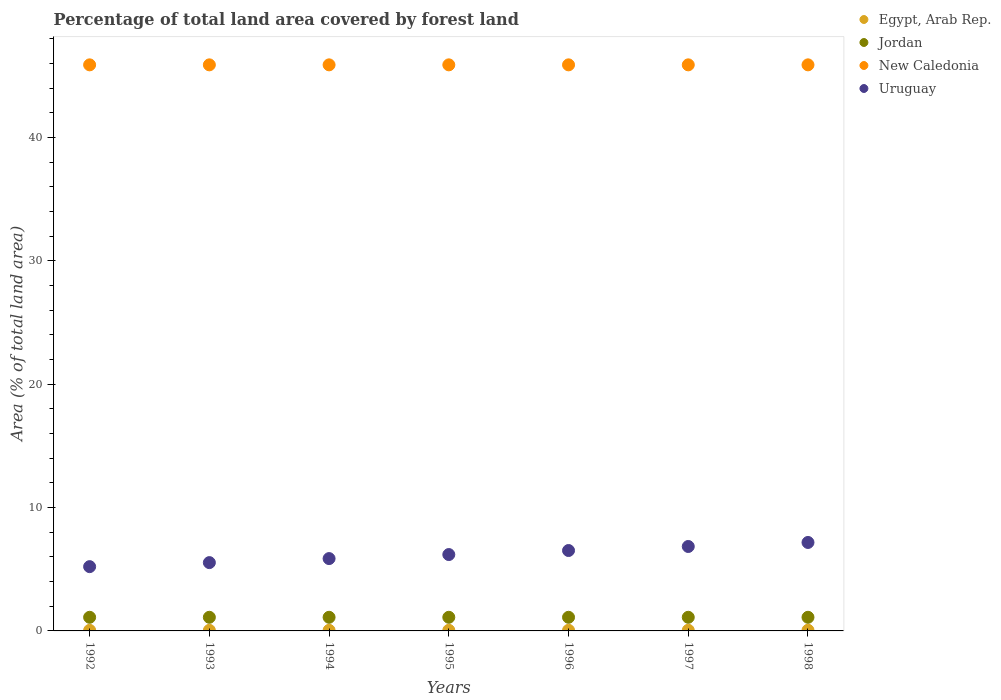How many different coloured dotlines are there?
Your response must be concise. 4. What is the percentage of forest land in New Caledonia in 1992?
Give a very brief answer. 45.9. Across all years, what is the maximum percentage of forest land in New Caledonia?
Give a very brief answer. 45.9. Across all years, what is the minimum percentage of forest land in Uruguay?
Provide a short and direct response. 5.21. In which year was the percentage of forest land in Uruguay minimum?
Keep it short and to the point. 1992. What is the total percentage of forest land in Jordan in the graph?
Provide a short and direct response. 7.73. What is the difference between the percentage of forest land in New Caledonia in 1993 and that in 1994?
Your answer should be very brief. 0. What is the difference between the percentage of forest land in Jordan in 1997 and the percentage of forest land in Uruguay in 1996?
Keep it short and to the point. -5.41. What is the average percentage of forest land in New Caledonia per year?
Provide a succinct answer. 45.9. In the year 1994, what is the difference between the percentage of forest land in Egypt, Arab Rep. and percentage of forest land in New Caledonia?
Keep it short and to the point. -45.85. What is the ratio of the percentage of forest land in Uruguay in 1994 to that in 1997?
Provide a succinct answer. 0.86. Is the percentage of forest land in Jordan in 1992 less than that in 1996?
Give a very brief answer. No. Is the difference between the percentage of forest land in Egypt, Arab Rep. in 1992 and 1995 greater than the difference between the percentage of forest land in New Caledonia in 1992 and 1995?
Ensure brevity in your answer.  No. What is the difference between the highest and the second highest percentage of forest land in Jordan?
Provide a short and direct response. 0. What is the difference between the highest and the lowest percentage of forest land in Jordan?
Your response must be concise. 0. Is the sum of the percentage of forest land in Egypt, Arab Rep. in 1994 and 1997 greater than the maximum percentage of forest land in New Caledonia across all years?
Ensure brevity in your answer.  No. Is it the case that in every year, the sum of the percentage of forest land in Jordan and percentage of forest land in New Caledonia  is greater than the percentage of forest land in Uruguay?
Your answer should be very brief. Yes. Does the percentage of forest land in Uruguay monotonically increase over the years?
Provide a succinct answer. Yes. Is the percentage of forest land in Egypt, Arab Rep. strictly greater than the percentage of forest land in New Caledonia over the years?
Your answer should be very brief. No. How many years are there in the graph?
Provide a short and direct response. 7. Does the graph contain grids?
Give a very brief answer. No. How many legend labels are there?
Your answer should be very brief. 4. What is the title of the graph?
Your answer should be compact. Percentage of total land area covered by forest land. What is the label or title of the X-axis?
Your answer should be compact. Years. What is the label or title of the Y-axis?
Keep it short and to the point. Area (% of total land area). What is the Area (% of total land area) of Egypt, Arab Rep. in 1992?
Your response must be concise. 0.05. What is the Area (% of total land area) of Jordan in 1992?
Provide a short and direct response. 1.1. What is the Area (% of total land area) in New Caledonia in 1992?
Offer a terse response. 45.9. What is the Area (% of total land area) in Uruguay in 1992?
Offer a very short reply. 5.21. What is the Area (% of total land area) of Egypt, Arab Rep. in 1993?
Provide a succinct answer. 0.05. What is the Area (% of total land area) in Jordan in 1993?
Ensure brevity in your answer.  1.1. What is the Area (% of total land area) of New Caledonia in 1993?
Offer a terse response. 45.9. What is the Area (% of total land area) in Uruguay in 1993?
Provide a succinct answer. 5.54. What is the Area (% of total land area) in Egypt, Arab Rep. in 1994?
Offer a very short reply. 0.05. What is the Area (% of total land area) in Jordan in 1994?
Ensure brevity in your answer.  1.1. What is the Area (% of total land area) of New Caledonia in 1994?
Make the answer very short. 45.9. What is the Area (% of total land area) in Uruguay in 1994?
Your answer should be very brief. 5.87. What is the Area (% of total land area) in Egypt, Arab Rep. in 1995?
Give a very brief answer. 0.05. What is the Area (% of total land area) of Jordan in 1995?
Provide a short and direct response. 1.1. What is the Area (% of total land area) in New Caledonia in 1995?
Keep it short and to the point. 45.9. What is the Area (% of total land area) of Uruguay in 1995?
Make the answer very short. 6.19. What is the Area (% of total land area) of Egypt, Arab Rep. in 1996?
Give a very brief answer. 0.05. What is the Area (% of total land area) of Jordan in 1996?
Provide a short and direct response. 1.1. What is the Area (% of total land area) in New Caledonia in 1996?
Give a very brief answer. 45.9. What is the Area (% of total land area) of Uruguay in 1996?
Your answer should be very brief. 6.52. What is the Area (% of total land area) of Egypt, Arab Rep. in 1997?
Give a very brief answer. 0.05. What is the Area (% of total land area) of Jordan in 1997?
Give a very brief answer. 1.1. What is the Area (% of total land area) of New Caledonia in 1997?
Make the answer very short. 45.9. What is the Area (% of total land area) of Uruguay in 1997?
Your response must be concise. 6.85. What is the Area (% of total land area) of Egypt, Arab Rep. in 1998?
Offer a terse response. 0.06. What is the Area (% of total land area) of Jordan in 1998?
Make the answer very short. 1.1. What is the Area (% of total land area) of New Caledonia in 1998?
Offer a terse response. 45.9. What is the Area (% of total land area) of Uruguay in 1998?
Offer a very short reply. 7.17. Across all years, what is the maximum Area (% of total land area) in Egypt, Arab Rep.?
Make the answer very short. 0.06. Across all years, what is the maximum Area (% of total land area) of Jordan?
Make the answer very short. 1.1. Across all years, what is the maximum Area (% of total land area) in New Caledonia?
Your answer should be very brief. 45.9. Across all years, what is the maximum Area (% of total land area) of Uruguay?
Your answer should be compact. 7.17. Across all years, what is the minimum Area (% of total land area) in Egypt, Arab Rep.?
Ensure brevity in your answer.  0.05. Across all years, what is the minimum Area (% of total land area) of Jordan?
Offer a terse response. 1.1. Across all years, what is the minimum Area (% of total land area) in New Caledonia?
Make the answer very short. 45.9. Across all years, what is the minimum Area (% of total land area) in Uruguay?
Ensure brevity in your answer.  5.21. What is the total Area (% of total land area) in Egypt, Arab Rep. in the graph?
Offer a very short reply. 0.36. What is the total Area (% of total land area) in Jordan in the graph?
Your answer should be very brief. 7.73. What is the total Area (% of total land area) in New Caledonia in the graph?
Your response must be concise. 321.28. What is the total Area (% of total land area) of Uruguay in the graph?
Ensure brevity in your answer.  43.34. What is the difference between the Area (% of total land area) of Egypt, Arab Rep. in 1992 and that in 1993?
Give a very brief answer. -0. What is the difference between the Area (% of total land area) of Uruguay in 1992 and that in 1993?
Your answer should be compact. -0.33. What is the difference between the Area (% of total land area) of Egypt, Arab Rep. in 1992 and that in 1994?
Provide a short and direct response. -0. What is the difference between the Area (% of total land area) in Jordan in 1992 and that in 1994?
Provide a short and direct response. 0. What is the difference between the Area (% of total land area) of Uruguay in 1992 and that in 1994?
Make the answer very short. -0.65. What is the difference between the Area (% of total land area) in Egypt, Arab Rep. in 1992 and that in 1995?
Ensure brevity in your answer.  -0. What is the difference between the Area (% of total land area) of Jordan in 1992 and that in 1995?
Make the answer very short. 0. What is the difference between the Area (% of total land area) in Uruguay in 1992 and that in 1995?
Give a very brief answer. -0.98. What is the difference between the Area (% of total land area) of Egypt, Arab Rep. in 1992 and that in 1996?
Your answer should be compact. -0.01. What is the difference between the Area (% of total land area) in Jordan in 1992 and that in 1996?
Your answer should be compact. 0. What is the difference between the Area (% of total land area) of Uruguay in 1992 and that in 1996?
Your response must be concise. -1.31. What is the difference between the Area (% of total land area) in Egypt, Arab Rep. in 1992 and that in 1997?
Provide a short and direct response. -0.01. What is the difference between the Area (% of total land area) in Uruguay in 1992 and that in 1997?
Give a very brief answer. -1.63. What is the difference between the Area (% of total land area) of Egypt, Arab Rep. in 1992 and that in 1998?
Provide a succinct answer. -0.01. What is the difference between the Area (% of total land area) in Uruguay in 1992 and that in 1998?
Ensure brevity in your answer.  -1.96. What is the difference between the Area (% of total land area) in Egypt, Arab Rep. in 1993 and that in 1994?
Your response must be concise. -0. What is the difference between the Area (% of total land area) of Uruguay in 1993 and that in 1994?
Ensure brevity in your answer.  -0.33. What is the difference between the Area (% of total land area) in Egypt, Arab Rep. in 1993 and that in 1995?
Your answer should be very brief. -0. What is the difference between the Area (% of total land area) in Jordan in 1993 and that in 1995?
Make the answer very short. 0. What is the difference between the Area (% of total land area) in New Caledonia in 1993 and that in 1995?
Give a very brief answer. 0. What is the difference between the Area (% of total land area) of Uruguay in 1993 and that in 1995?
Make the answer very short. -0.65. What is the difference between the Area (% of total land area) in Egypt, Arab Rep. in 1993 and that in 1996?
Give a very brief answer. -0. What is the difference between the Area (% of total land area) in Uruguay in 1993 and that in 1996?
Offer a very short reply. -0.98. What is the difference between the Area (% of total land area) in Egypt, Arab Rep. in 1993 and that in 1997?
Make the answer very short. -0.01. What is the difference between the Area (% of total land area) of Jordan in 1993 and that in 1997?
Offer a very short reply. 0. What is the difference between the Area (% of total land area) in Uruguay in 1993 and that in 1997?
Offer a very short reply. -1.31. What is the difference between the Area (% of total land area) in Egypt, Arab Rep. in 1993 and that in 1998?
Your answer should be compact. -0.01. What is the difference between the Area (% of total land area) in Jordan in 1993 and that in 1998?
Give a very brief answer. 0. What is the difference between the Area (% of total land area) in New Caledonia in 1993 and that in 1998?
Your answer should be very brief. 0. What is the difference between the Area (% of total land area) in Uruguay in 1993 and that in 1998?
Your answer should be compact. -1.63. What is the difference between the Area (% of total land area) of Egypt, Arab Rep. in 1994 and that in 1995?
Your response must be concise. -0. What is the difference between the Area (% of total land area) in Uruguay in 1994 and that in 1995?
Offer a very short reply. -0.33. What is the difference between the Area (% of total land area) of Egypt, Arab Rep. in 1994 and that in 1996?
Ensure brevity in your answer.  -0. What is the difference between the Area (% of total land area) of Uruguay in 1994 and that in 1996?
Ensure brevity in your answer.  -0.65. What is the difference between the Area (% of total land area) in Egypt, Arab Rep. in 1994 and that in 1997?
Make the answer very short. -0. What is the difference between the Area (% of total land area) in New Caledonia in 1994 and that in 1997?
Provide a short and direct response. 0. What is the difference between the Area (% of total land area) in Uruguay in 1994 and that in 1997?
Your answer should be very brief. -0.98. What is the difference between the Area (% of total land area) of Egypt, Arab Rep. in 1994 and that in 1998?
Your answer should be compact. -0.01. What is the difference between the Area (% of total land area) of Jordan in 1994 and that in 1998?
Your response must be concise. 0. What is the difference between the Area (% of total land area) of Uruguay in 1994 and that in 1998?
Give a very brief answer. -1.31. What is the difference between the Area (% of total land area) in Egypt, Arab Rep. in 1995 and that in 1996?
Provide a short and direct response. -0. What is the difference between the Area (% of total land area) in Jordan in 1995 and that in 1996?
Your response must be concise. 0. What is the difference between the Area (% of total land area) of New Caledonia in 1995 and that in 1996?
Ensure brevity in your answer.  0. What is the difference between the Area (% of total land area) of Uruguay in 1995 and that in 1996?
Provide a succinct answer. -0.33. What is the difference between the Area (% of total land area) of Egypt, Arab Rep. in 1995 and that in 1997?
Ensure brevity in your answer.  -0. What is the difference between the Area (% of total land area) of Jordan in 1995 and that in 1997?
Offer a very short reply. 0. What is the difference between the Area (% of total land area) in Uruguay in 1995 and that in 1997?
Give a very brief answer. -0.65. What is the difference between the Area (% of total land area) of Egypt, Arab Rep. in 1995 and that in 1998?
Ensure brevity in your answer.  -0. What is the difference between the Area (% of total land area) of New Caledonia in 1995 and that in 1998?
Your answer should be very brief. 0. What is the difference between the Area (% of total land area) in Uruguay in 1995 and that in 1998?
Your response must be concise. -0.98. What is the difference between the Area (% of total land area) of Egypt, Arab Rep. in 1996 and that in 1997?
Provide a short and direct response. -0. What is the difference between the Area (% of total land area) of Jordan in 1996 and that in 1997?
Ensure brevity in your answer.  0. What is the difference between the Area (% of total land area) in New Caledonia in 1996 and that in 1997?
Your response must be concise. 0. What is the difference between the Area (% of total land area) in Uruguay in 1996 and that in 1997?
Provide a succinct answer. -0.33. What is the difference between the Area (% of total land area) in Egypt, Arab Rep. in 1996 and that in 1998?
Give a very brief answer. -0. What is the difference between the Area (% of total land area) of Jordan in 1996 and that in 1998?
Make the answer very short. 0. What is the difference between the Area (% of total land area) in New Caledonia in 1996 and that in 1998?
Your answer should be very brief. 0. What is the difference between the Area (% of total land area) in Uruguay in 1996 and that in 1998?
Your answer should be very brief. -0.65. What is the difference between the Area (% of total land area) in Egypt, Arab Rep. in 1997 and that in 1998?
Offer a very short reply. -0. What is the difference between the Area (% of total land area) of New Caledonia in 1997 and that in 1998?
Give a very brief answer. 0. What is the difference between the Area (% of total land area) of Uruguay in 1997 and that in 1998?
Your answer should be very brief. -0.33. What is the difference between the Area (% of total land area) in Egypt, Arab Rep. in 1992 and the Area (% of total land area) in Jordan in 1993?
Give a very brief answer. -1.06. What is the difference between the Area (% of total land area) in Egypt, Arab Rep. in 1992 and the Area (% of total land area) in New Caledonia in 1993?
Offer a terse response. -45.85. What is the difference between the Area (% of total land area) of Egypt, Arab Rep. in 1992 and the Area (% of total land area) of Uruguay in 1993?
Provide a succinct answer. -5.49. What is the difference between the Area (% of total land area) of Jordan in 1992 and the Area (% of total land area) of New Caledonia in 1993?
Your answer should be compact. -44.79. What is the difference between the Area (% of total land area) of Jordan in 1992 and the Area (% of total land area) of Uruguay in 1993?
Keep it short and to the point. -4.43. What is the difference between the Area (% of total land area) of New Caledonia in 1992 and the Area (% of total land area) of Uruguay in 1993?
Make the answer very short. 40.36. What is the difference between the Area (% of total land area) in Egypt, Arab Rep. in 1992 and the Area (% of total land area) in Jordan in 1994?
Your answer should be compact. -1.06. What is the difference between the Area (% of total land area) of Egypt, Arab Rep. in 1992 and the Area (% of total land area) of New Caledonia in 1994?
Offer a terse response. -45.85. What is the difference between the Area (% of total land area) in Egypt, Arab Rep. in 1992 and the Area (% of total land area) in Uruguay in 1994?
Make the answer very short. -5.82. What is the difference between the Area (% of total land area) in Jordan in 1992 and the Area (% of total land area) in New Caledonia in 1994?
Offer a terse response. -44.79. What is the difference between the Area (% of total land area) in Jordan in 1992 and the Area (% of total land area) in Uruguay in 1994?
Ensure brevity in your answer.  -4.76. What is the difference between the Area (% of total land area) of New Caledonia in 1992 and the Area (% of total land area) of Uruguay in 1994?
Provide a short and direct response. 40.03. What is the difference between the Area (% of total land area) of Egypt, Arab Rep. in 1992 and the Area (% of total land area) of Jordan in 1995?
Your answer should be very brief. -1.06. What is the difference between the Area (% of total land area) of Egypt, Arab Rep. in 1992 and the Area (% of total land area) of New Caledonia in 1995?
Keep it short and to the point. -45.85. What is the difference between the Area (% of total land area) of Egypt, Arab Rep. in 1992 and the Area (% of total land area) of Uruguay in 1995?
Your answer should be very brief. -6.14. What is the difference between the Area (% of total land area) in Jordan in 1992 and the Area (% of total land area) in New Caledonia in 1995?
Provide a succinct answer. -44.79. What is the difference between the Area (% of total land area) in Jordan in 1992 and the Area (% of total land area) in Uruguay in 1995?
Your response must be concise. -5.09. What is the difference between the Area (% of total land area) in New Caledonia in 1992 and the Area (% of total land area) in Uruguay in 1995?
Offer a very short reply. 39.7. What is the difference between the Area (% of total land area) in Egypt, Arab Rep. in 1992 and the Area (% of total land area) in Jordan in 1996?
Keep it short and to the point. -1.06. What is the difference between the Area (% of total land area) of Egypt, Arab Rep. in 1992 and the Area (% of total land area) of New Caledonia in 1996?
Your answer should be very brief. -45.85. What is the difference between the Area (% of total land area) of Egypt, Arab Rep. in 1992 and the Area (% of total land area) of Uruguay in 1996?
Your answer should be very brief. -6.47. What is the difference between the Area (% of total land area) of Jordan in 1992 and the Area (% of total land area) of New Caledonia in 1996?
Your answer should be compact. -44.79. What is the difference between the Area (% of total land area) in Jordan in 1992 and the Area (% of total land area) in Uruguay in 1996?
Your response must be concise. -5.41. What is the difference between the Area (% of total land area) in New Caledonia in 1992 and the Area (% of total land area) in Uruguay in 1996?
Keep it short and to the point. 39.38. What is the difference between the Area (% of total land area) of Egypt, Arab Rep. in 1992 and the Area (% of total land area) of Jordan in 1997?
Your answer should be very brief. -1.06. What is the difference between the Area (% of total land area) of Egypt, Arab Rep. in 1992 and the Area (% of total land area) of New Caledonia in 1997?
Make the answer very short. -45.85. What is the difference between the Area (% of total land area) in Egypt, Arab Rep. in 1992 and the Area (% of total land area) in Uruguay in 1997?
Your response must be concise. -6.8. What is the difference between the Area (% of total land area) in Jordan in 1992 and the Area (% of total land area) in New Caledonia in 1997?
Give a very brief answer. -44.79. What is the difference between the Area (% of total land area) of Jordan in 1992 and the Area (% of total land area) of Uruguay in 1997?
Ensure brevity in your answer.  -5.74. What is the difference between the Area (% of total land area) of New Caledonia in 1992 and the Area (% of total land area) of Uruguay in 1997?
Offer a very short reply. 39.05. What is the difference between the Area (% of total land area) of Egypt, Arab Rep. in 1992 and the Area (% of total land area) of Jordan in 1998?
Make the answer very short. -1.06. What is the difference between the Area (% of total land area) in Egypt, Arab Rep. in 1992 and the Area (% of total land area) in New Caledonia in 1998?
Offer a very short reply. -45.85. What is the difference between the Area (% of total land area) of Egypt, Arab Rep. in 1992 and the Area (% of total land area) of Uruguay in 1998?
Make the answer very short. -7.13. What is the difference between the Area (% of total land area) in Jordan in 1992 and the Area (% of total land area) in New Caledonia in 1998?
Your answer should be compact. -44.79. What is the difference between the Area (% of total land area) of Jordan in 1992 and the Area (% of total land area) of Uruguay in 1998?
Offer a very short reply. -6.07. What is the difference between the Area (% of total land area) in New Caledonia in 1992 and the Area (% of total land area) in Uruguay in 1998?
Provide a short and direct response. 38.72. What is the difference between the Area (% of total land area) of Egypt, Arab Rep. in 1993 and the Area (% of total land area) of Jordan in 1994?
Offer a very short reply. -1.06. What is the difference between the Area (% of total land area) of Egypt, Arab Rep. in 1993 and the Area (% of total land area) of New Caledonia in 1994?
Give a very brief answer. -45.85. What is the difference between the Area (% of total land area) in Egypt, Arab Rep. in 1993 and the Area (% of total land area) in Uruguay in 1994?
Offer a terse response. -5.82. What is the difference between the Area (% of total land area) of Jordan in 1993 and the Area (% of total land area) of New Caledonia in 1994?
Your answer should be compact. -44.79. What is the difference between the Area (% of total land area) of Jordan in 1993 and the Area (% of total land area) of Uruguay in 1994?
Offer a very short reply. -4.76. What is the difference between the Area (% of total land area) in New Caledonia in 1993 and the Area (% of total land area) in Uruguay in 1994?
Your answer should be compact. 40.03. What is the difference between the Area (% of total land area) of Egypt, Arab Rep. in 1993 and the Area (% of total land area) of Jordan in 1995?
Make the answer very short. -1.06. What is the difference between the Area (% of total land area) in Egypt, Arab Rep. in 1993 and the Area (% of total land area) in New Caledonia in 1995?
Ensure brevity in your answer.  -45.85. What is the difference between the Area (% of total land area) of Egypt, Arab Rep. in 1993 and the Area (% of total land area) of Uruguay in 1995?
Give a very brief answer. -6.14. What is the difference between the Area (% of total land area) in Jordan in 1993 and the Area (% of total land area) in New Caledonia in 1995?
Make the answer very short. -44.79. What is the difference between the Area (% of total land area) in Jordan in 1993 and the Area (% of total land area) in Uruguay in 1995?
Offer a terse response. -5.09. What is the difference between the Area (% of total land area) in New Caledonia in 1993 and the Area (% of total land area) in Uruguay in 1995?
Make the answer very short. 39.7. What is the difference between the Area (% of total land area) of Egypt, Arab Rep. in 1993 and the Area (% of total land area) of Jordan in 1996?
Give a very brief answer. -1.06. What is the difference between the Area (% of total land area) of Egypt, Arab Rep. in 1993 and the Area (% of total land area) of New Caledonia in 1996?
Provide a short and direct response. -45.85. What is the difference between the Area (% of total land area) of Egypt, Arab Rep. in 1993 and the Area (% of total land area) of Uruguay in 1996?
Offer a terse response. -6.47. What is the difference between the Area (% of total land area) in Jordan in 1993 and the Area (% of total land area) in New Caledonia in 1996?
Your answer should be compact. -44.79. What is the difference between the Area (% of total land area) in Jordan in 1993 and the Area (% of total land area) in Uruguay in 1996?
Your answer should be compact. -5.41. What is the difference between the Area (% of total land area) of New Caledonia in 1993 and the Area (% of total land area) of Uruguay in 1996?
Your answer should be very brief. 39.38. What is the difference between the Area (% of total land area) in Egypt, Arab Rep. in 1993 and the Area (% of total land area) in Jordan in 1997?
Offer a terse response. -1.06. What is the difference between the Area (% of total land area) in Egypt, Arab Rep. in 1993 and the Area (% of total land area) in New Caledonia in 1997?
Your answer should be compact. -45.85. What is the difference between the Area (% of total land area) of Egypt, Arab Rep. in 1993 and the Area (% of total land area) of Uruguay in 1997?
Offer a terse response. -6.8. What is the difference between the Area (% of total land area) of Jordan in 1993 and the Area (% of total land area) of New Caledonia in 1997?
Offer a terse response. -44.79. What is the difference between the Area (% of total land area) of Jordan in 1993 and the Area (% of total land area) of Uruguay in 1997?
Your response must be concise. -5.74. What is the difference between the Area (% of total land area) in New Caledonia in 1993 and the Area (% of total land area) in Uruguay in 1997?
Offer a very short reply. 39.05. What is the difference between the Area (% of total land area) in Egypt, Arab Rep. in 1993 and the Area (% of total land area) in Jordan in 1998?
Provide a short and direct response. -1.06. What is the difference between the Area (% of total land area) of Egypt, Arab Rep. in 1993 and the Area (% of total land area) of New Caledonia in 1998?
Provide a succinct answer. -45.85. What is the difference between the Area (% of total land area) in Egypt, Arab Rep. in 1993 and the Area (% of total land area) in Uruguay in 1998?
Provide a succinct answer. -7.12. What is the difference between the Area (% of total land area) of Jordan in 1993 and the Area (% of total land area) of New Caledonia in 1998?
Offer a very short reply. -44.79. What is the difference between the Area (% of total land area) in Jordan in 1993 and the Area (% of total land area) in Uruguay in 1998?
Ensure brevity in your answer.  -6.07. What is the difference between the Area (% of total land area) in New Caledonia in 1993 and the Area (% of total land area) in Uruguay in 1998?
Make the answer very short. 38.72. What is the difference between the Area (% of total land area) of Egypt, Arab Rep. in 1994 and the Area (% of total land area) of Jordan in 1995?
Your response must be concise. -1.05. What is the difference between the Area (% of total land area) in Egypt, Arab Rep. in 1994 and the Area (% of total land area) in New Caledonia in 1995?
Keep it short and to the point. -45.85. What is the difference between the Area (% of total land area) in Egypt, Arab Rep. in 1994 and the Area (% of total land area) in Uruguay in 1995?
Keep it short and to the point. -6.14. What is the difference between the Area (% of total land area) of Jordan in 1994 and the Area (% of total land area) of New Caledonia in 1995?
Provide a short and direct response. -44.79. What is the difference between the Area (% of total land area) of Jordan in 1994 and the Area (% of total land area) of Uruguay in 1995?
Your response must be concise. -5.09. What is the difference between the Area (% of total land area) in New Caledonia in 1994 and the Area (% of total land area) in Uruguay in 1995?
Your answer should be very brief. 39.7. What is the difference between the Area (% of total land area) of Egypt, Arab Rep. in 1994 and the Area (% of total land area) of Jordan in 1996?
Your answer should be very brief. -1.05. What is the difference between the Area (% of total land area) of Egypt, Arab Rep. in 1994 and the Area (% of total land area) of New Caledonia in 1996?
Make the answer very short. -45.85. What is the difference between the Area (% of total land area) of Egypt, Arab Rep. in 1994 and the Area (% of total land area) of Uruguay in 1996?
Your answer should be compact. -6.47. What is the difference between the Area (% of total land area) in Jordan in 1994 and the Area (% of total land area) in New Caledonia in 1996?
Ensure brevity in your answer.  -44.79. What is the difference between the Area (% of total land area) of Jordan in 1994 and the Area (% of total land area) of Uruguay in 1996?
Your response must be concise. -5.41. What is the difference between the Area (% of total land area) in New Caledonia in 1994 and the Area (% of total land area) in Uruguay in 1996?
Your answer should be very brief. 39.38. What is the difference between the Area (% of total land area) of Egypt, Arab Rep. in 1994 and the Area (% of total land area) of Jordan in 1997?
Provide a short and direct response. -1.05. What is the difference between the Area (% of total land area) in Egypt, Arab Rep. in 1994 and the Area (% of total land area) in New Caledonia in 1997?
Your response must be concise. -45.85. What is the difference between the Area (% of total land area) of Egypt, Arab Rep. in 1994 and the Area (% of total land area) of Uruguay in 1997?
Give a very brief answer. -6.8. What is the difference between the Area (% of total land area) in Jordan in 1994 and the Area (% of total land area) in New Caledonia in 1997?
Provide a short and direct response. -44.79. What is the difference between the Area (% of total land area) of Jordan in 1994 and the Area (% of total land area) of Uruguay in 1997?
Ensure brevity in your answer.  -5.74. What is the difference between the Area (% of total land area) of New Caledonia in 1994 and the Area (% of total land area) of Uruguay in 1997?
Make the answer very short. 39.05. What is the difference between the Area (% of total land area) of Egypt, Arab Rep. in 1994 and the Area (% of total land area) of Jordan in 1998?
Offer a very short reply. -1.05. What is the difference between the Area (% of total land area) of Egypt, Arab Rep. in 1994 and the Area (% of total land area) of New Caledonia in 1998?
Give a very brief answer. -45.85. What is the difference between the Area (% of total land area) of Egypt, Arab Rep. in 1994 and the Area (% of total land area) of Uruguay in 1998?
Keep it short and to the point. -7.12. What is the difference between the Area (% of total land area) of Jordan in 1994 and the Area (% of total land area) of New Caledonia in 1998?
Provide a succinct answer. -44.79. What is the difference between the Area (% of total land area) of Jordan in 1994 and the Area (% of total land area) of Uruguay in 1998?
Offer a terse response. -6.07. What is the difference between the Area (% of total land area) of New Caledonia in 1994 and the Area (% of total land area) of Uruguay in 1998?
Your answer should be compact. 38.72. What is the difference between the Area (% of total land area) in Egypt, Arab Rep. in 1995 and the Area (% of total land area) in Jordan in 1996?
Give a very brief answer. -1.05. What is the difference between the Area (% of total land area) in Egypt, Arab Rep. in 1995 and the Area (% of total land area) in New Caledonia in 1996?
Your answer should be compact. -45.85. What is the difference between the Area (% of total land area) in Egypt, Arab Rep. in 1995 and the Area (% of total land area) in Uruguay in 1996?
Your response must be concise. -6.47. What is the difference between the Area (% of total land area) in Jordan in 1995 and the Area (% of total land area) in New Caledonia in 1996?
Provide a succinct answer. -44.79. What is the difference between the Area (% of total land area) of Jordan in 1995 and the Area (% of total land area) of Uruguay in 1996?
Provide a succinct answer. -5.41. What is the difference between the Area (% of total land area) in New Caledonia in 1995 and the Area (% of total land area) in Uruguay in 1996?
Keep it short and to the point. 39.38. What is the difference between the Area (% of total land area) of Egypt, Arab Rep. in 1995 and the Area (% of total land area) of Jordan in 1997?
Your answer should be very brief. -1.05. What is the difference between the Area (% of total land area) of Egypt, Arab Rep. in 1995 and the Area (% of total land area) of New Caledonia in 1997?
Offer a terse response. -45.85. What is the difference between the Area (% of total land area) in Egypt, Arab Rep. in 1995 and the Area (% of total land area) in Uruguay in 1997?
Offer a terse response. -6.79. What is the difference between the Area (% of total land area) in Jordan in 1995 and the Area (% of total land area) in New Caledonia in 1997?
Keep it short and to the point. -44.79. What is the difference between the Area (% of total land area) in Jordan in 1995 and the Area (% of total land area) in Uruguay in 1997?
Make the answer very short. -5.74. What is the difference between the Area (% of total land area) of New Caledonia in 1995 and the Area (% of total land area) of Uruguay in 1997?
Offer a terse response. 39.05. What is the difference between the Area (% of total land area) in Egypt, Arab Rep. in 1995 and the Area (% of total land area) in Jordan in 1998?
Your answer should be very brief. -1.05. What is the difference between the Area (% of total land area) of Egypt, Arab Rep. in 1995 and the Area (% of total land area) of New Caledonia in 1998?
Your response must be concise. -45.85. What is the difference between the Area (% of total land area) in Egypt, Arab Rep. in 1995 and the Area (% of total land area) in Uruguay in 1998?
Your answer should be compact. -7.12. What is the difference between the Area (% of total land area) of Jordan in 1995 and the Area (% of total land area) of New Caledonia in 1998?
Offer a very short reply. -44.79. What is the difference between the Area (% of total land area) in Jordan in 1995 and the Area (% of total land area) in Uruguay in 1998?
Your response must be concise. -6.07. What is the difference between the Area (% of total land area) in New Caledonia in 1995 and the Area (% of total land area) in Uruguay in 1998?
Provide a succinct answer. 38.72. What is the difference between the Area (% of total land area) in Egypt, Arab Rep. in 1996 and the Area (% of total land area) in Jordan in 1997?
Your answer should be compact. -1.05. What is the difference between the Area (% of total land area) of Egypt, Arab Rep. in 1996 and the Area (% of total land area) of New Caledonia in 1997?
Your response must be concise. -45.84. What is the difference between the Area (% of total land area) of Egypt, Arab Rep. in 1996 and the Area (% of total land area) of Uruguay in 1997?
Offer a terse response. -6.79. What is the difference between the Area (% of total land area) of Jordan in 1996 and the Area (% of total land area) of New Caledonia in 1997?
Provide a succinct answer. -44.79. What is the difference between the Area (% of total land area) of Jordan in 1996 and the Area (% of total land area) of Uruguay in 1997?
Give a very brief answer. -5.74. What is the difference between the Area (% of total land area) of New Caledonia in 1996 and the Area (% of total land area) of Uruguay in 1997?
Ensure brevity in your answer.  39.05. What is the difference between the Area (% of total land area) of Egypt, Arab Rep. in 1996 and the Area (% of total land area) of Jordan in 1998?
Keep it short and to the point. -1.05. What is the difference between the Area (% of total land area) in Egypt, Arab Rep. in 1996 and the Area (% of total land area) in New Caledonia in 1998?
Provide a short and direct response. -45.84. What is the difference between the Area (% of total land area) in Egypt, Arab Rep. in 1996 and the Area (% of total land area) in Uruguay in 1998?
Your response must be concise. -7.12. What is the difference between the Area (% of total land area) of Jordan in 1996 and the Area (% of total land area) of New Caledonia in 1998?
Provide a short and direct response. -44.79. What is the difference between the Area (% of total land area) in Jordan in 1996 and the Area (% of total land area) in Uruguay in 1998?
Keep it short and to the point. -6.07. What is the difference between the Area (% of total land area) in New Caledonia in 1996 and the Area (% of total land area) in Uruguay in 1998?
Your answer should be compact. 38.72. What is the difference between the Area (% of total land area) in Egypt, Arab Rep. in 1997 and the Area (% of total land area) in Jordan in 1998?
Provide a succinct answer. -1.05. What is the difference between the Area (% of total land area) of Egypt, Arab Rep. in 1997 and the Area (% of total land area) of New Caledonia in 1998?
Ensure brevity in your answer.  -45.84. What is the difference between the Area (% of total land area) of Egypt, Arab Rep. in 1997 and the Area (% of total land area) of Uruguay in 1998?
Your response must be concise. -7.12. What is the difference between the Area (% of total land area) in Jordan in 1997 and the Area (% of total land area) in New Caledonia in 1998?
Your answer should be very brief. -44.79. What is the difference between the Area (% of total land area) of Jordan in 1997 and the Area (% of total land area) of Uruguay in 1998?
Your response must be concise. -6.07. What is the difference between the Area (% of total land area) in New Caledonia in 1997 and the Area (% of total land area) in Uruguay in 1998?
Ensure brevity in your answer.  38.72. What is the average Area (% of total land area) of Egypt, Arab Rep. per year?
Your answer should be very brief. 0.05. What is the average Area (% of total land area) of Jordan per year?
Give a very brief answer. 1.1. What is the average Area (% of total land area) of New Caledonia per year?
Give a very brief answer. 45.9. What is the average Area (% of total land area) of Uruguay per year?
Your response must be concise. 6.19. In the year 1992, what is the difference between the Area (% of total land area) in Egypt, Arab Rep. and Area (% of total land area) in Jordan?
Provide a short and direct response. -1.06. In the year 1992, what is the difference between the Area (% of total land area) in Egypt, Arab Rep. and Area (% of total land area) in New Caledonia?
Keep it short and to the point. -45.85. In the year 1992, what is the difference between the Area (% of total land area) in Egypt, Arab Rep. and Area (% of total land area) in Uruguay?
Your response must be concise. -5.16. In the year 1992, what is the difference between the Area (% of total land area) in Jordan and Area (% of total land area) in New Caledonia?
Your answer should be very brief. -44.79. In the year 1992, what is the difference between the Area (% of total land area) in Jordan and Area (% of total land area) in Uruguay?
Your answer should be very brief. -4.11. In the year 1992, what is the difference between the Area (% of total land area) of New Caledonia and Area (% of total land area) of Uruguay?
Your response must be concise. 40.69. In the year 1993, what is the difference between the Area (% of total land area) of Egypt, Arab Rep. and Area (% of total land area) of Jordan?
Ensure brevity in your answer.  -1.06. In the year 1993, what is the difference between the Area (% of total land area) in Egypt, Arab Rep. and Area (% of total land area) in New Caledonia?
Make the answer very short. -45.85. In the year 1993, what is the difference between the Area (% of total land area) of Egypt, Arab Rep. and Area (% of total land area) of Uruguay?
Give a very brief answer. -5.49. In the year 1993, what is the difference between the Area (% of total land area) of Jordan and Area (% of total land area) of New Caledonia?
Your answer should be very brief. -44.79. In the year 1993, what is the difference between the Area (% of total land area) of Jordan and Area (% of total land area) of Uruguay?
Provide a short and direct response. -4.43. In the year 1993, what is the difference between the Area (% of total land area) of New Caledonia and Area (% of total land area) of Uruguay?
Keep it short and to the point. 40.36. In the year 1994, what is the difference between the Area (% of total land area) of Egypt, Arab Rep. and Area (% of total land area) of Jordan?
Provide a short and direct response. -1.05. In the year 1994, what is the difference between the Area (% of total land area) in Egypt, Arab Rep. and Area (% of total land area) in New Caledonia?
Your response must be concise. -45.85. In the year 1994, what is the difference between the Area (% of total land area) in Egypt, Arab Rep. and Area (% of total land area) in Uruguay?
Offer a terse response. -5.82. In the year 1994, what is the difference between the Area (% of total land area) in Jordan and Area (% of total land area) in New Caledonia?
Your answer should be very brief. -44.79. In the year 1994, what is the difference between the Area (% of total land area) in Jordan and Area (% of total land area) in Uruguay?
Provide a short and direct response. -4.76. In the year 1994, what is the difference between the Area (% of total land area) of New Caledonia and Area (% of total land area) of Uruguay?
Ensure brevity in your answer.  40.03. In the year 1995, what is the difference between the Area (% of total land area) in Egypt, Arab Rep. and Area (% of total land area) in Jordan?
Offer a terse response. -1.05. In the year 1995, what is the difference between the Area (% of total land area) of Egypt, Arab Rep. and Area (% of total land area) of New Caledonia?
Your response must be concise. -45.85. In the year 1995, what is the difference between the Area (% of total land area) of Egypt, Arab Rep. and Area (% of total land area) of Uruguay?
Make the answer very short. -6.14. In the year 1995, what is the difference between the Area (% of total land area) in Jordan and Area (% of total land area) in New Caledonia?
Provide a short and direct response. -44.79. In the year 1995, what is the difference between the Area (% of total land area) in Jordan and Area (% of total land area) in Uruguay?
Keep it short and to the point. -5.09. In the year 1995, what is the difference between the Area (% of total land area) in New Caledonia and Area (% of total land area) in Uruguay?
Your answer should be very brief. 39.7. In the year 1996, what is the difference between the Area (% of total land area) in Egypt, Arab Rep. and Area (% of total land area) in Jordan?
Your answer should be very brief. -1.05. In the year 1996, what is the difference between the Area (% of total land area) in Egypt, Arab Rep. and Area (% of total land area) in New Caledonia?
Give a very brief answer. -45.84. In the year 1996, what is the difference between the Area (% of total land area) in Egypt, Arab Rep. and Area (% of total land area) in Uruguay?
Keep it short and to the point. -6.47. In the year 1996, what is the difference between the Area (% of total land area) of Jordan and Area (% of total land area) of New Caledonia?
Your response must be concise. -44.79. In the year 1996, what is the difference between the Area (% of total land area) in Jordan and Area (% of total land area) in Uruguay?
Offer a terse response. -5.41. In the year 1996, what is the difference between the Area (% of total land area) in New Caledonia and Area (% of total land area) in Uruguay?
Provide a short and direct response. 39.38. In the year 1997, what is the difference between the Area (% of total land area) of Egypt, Arab Rep. and Area (% of total land area) of Jordan?
Provide a succinct answer. -1.05. In the year 1997, what is the difference between the Area (% of total land area) of Egypt, Arab Rep. and Area (% of total land area) of New Caledonia?
Offer a terse response. -45.84. In the year 1997, what is the difference between the Area (% of total land area) of Egypt, Arab Rep. and Area (% of total land area) of Uruguay?
Keep it short and to the point. -6.79. In the year 1997, what is the difference between the Area (% of total land area) in Jordan and Area (% of total land area) in New Caledonia?
Offer a terse response. -44.79. In the year 1997, what is the difference between the Area (% of total land area) of Jordan and Area (% of total land area) of Uruguay?
Keep it short and to the point. -5.74. In the year 1997, what is the difference between the Area (% of total land area) of New Caledonia and Area (% of total land area) of Uruguay?
Keep it short and to the point. 39.05. In the year 1998, what is the difference between the Area (% of total land area) in Egypt, Arab Rep. and Area (% of total land area) in Jordan?
Your answer should be compact. -1.05. In the year 1998, what is the difference between the Area (% of total land area) in Egypt, Arab Rep. and Area (% of total land area) in New Caledonia?
Your answer should be very brief. -45.84. In the year 1998, what is the difference between the Area (% of total land area) in Egypt, Arab Rep. and Area (% of total land area) in Uruguay?
Provide a succinct answer. -7.12. In the year 1998, what is the difference between the Area (% of total land area) of Jordan and Area (% of total land area) of New Caledonia?
Your answer should be compact. -44.79. In the year 1998, what is the difference between the Area (% of total land area) of Jordan and Area (% of total land area) of Uruguay?
Offer a terse response. -6.07. In the year 1998, what is the difference between the Area (% of total land area) of New Caledonia and Area (% of total land area) of Uruguay?
Your answer should be compact. 38.72. What is the ratio of the Area (% of total land area) in Egypt, Arab Rep. in 1992 to that in 1993?
Your answer should be compact. 0.97. What is the ratio of the Area (% of total land area) of Jordan in 1992 to that in 1993?
Your answer should be very brief. 1. What is the ratio of the Area (% of total land area) in New Caledonia in 1992 to that in 1993?
Your response must be concise. 1. What is the ratio of the Area (% of total land area) of Uruguay in 1992 to that in 1993?
Provide a short and direct response. 0.94. What is the ratio of the Area (% of total land area) in Egypt, Arab Rep. in 1992 to that in 1994?
Your answer should be very brief. 0.94. What is the ratio of the Area (% of total land area) of Jordan in 1992 to that in 1994?
Your answer should be compact. 1. What is the ratio of the Area (% of total land area) in New Caledonia in 1992 to that in 1994?
Offer a terse response. 1. What is the ratio of the Area (% of total land area) in Uruguay in 1992 to that in 1994?
Give a very brief answer. 0.89. What is the ratio of the Area (% of total land area) of Egypt, Arab Rep. in 1992 to that in 1995?
Give a very brief answer. 0.91. What is the ratio of the Area (% of total land area) in Jordan in 1992 to that in 1995?
Make the answer very short. 1. What is the ratio of the Area (% of total land area) of New Caledonia in 1992 to that in 1995?
Provide a short and direct response. 1. What is the ratio of the Area (% of total land area) in Uruguay in 1992 to that in 1995?
Give a very brief answer. 0.84. What is the ratio of the Area (% of total land area) of Egypt, Arab Rep. in 1992 to that in 1996?
Provide a succinct answer. 0.89. What is the ratio of the Area (% of total land area) of Jordan in 1992 to that in 1996?
Your answer should be compact. 1. What is the ratio of the Area (% of total land area) of Uruguay in 1992 to that in 1996?
Your answer should be compact. 0.8. What is the ratio of the Area (% of total land area) of Egypt, Arab Rep. in 1992 to that in 1997?
Provide a short and direct response. 0.86. What is the ratio of the Area (% of total land area) in Uruguay in 1992 to that in 1997?
Make the answer very short. 0.76. What is the ratio of the Area (% of total land area) of Egypt, Arab Rep. in 1992 to that in 1998?
Offer a terse response. 0.84. What is the ratio of the Area (% of total land area) in Jordan in 1992 to that in 1998?
Offer a terse response. 1. What is the ratio of the Area (% of total land area) in Uruguay in 1992 to that in 1998?
Keep it short and to the point. 0.73. What is the ratio of the Area (% of total land area) in Egypt, Arab Rep. in 1993 to that in 1994?
Your answer should be compact. 0.97. What is the ratio of the Area (% of total land area) in Jordan in 1993 to that in 1994?
Provide a succinct answer. 1. What is the ratio of the Area (% of total land area) of Uruguay in 1993 to that in 1994?
Your answer should be compact. 0.94. What is the ratio of the Area (% of total land area) in Egypt, Arab Rep. in 1993 to that in 1995?
Provide a short and direct response. 0.94. What is the ratio of the Area (% of total land area) in Jordan in 1993 to that in 1995?
Your answer should be very brief. 1. What is the ratio of the Area (% of total land area) of New Caledonia in 1993 to that in 1995?
Offer a terse response. 1. What is the ratio of the Area (% of total land area) in Uruguay in 1993 to that in 1995?
Make the answer very short. 0.89. What is the ratio of the Area (% of total land area) in Egypt, Arab Rep. in 1993 to that in 1996?
Keep it short and to the point. 0.92. What is the ratio of the Area (% of total land area) in Jordan in 1993 to that in 1996?
Ensure brevity in your answer.  1. What is the ratio of the Area (% of total land area) of New Caledonia in 1993 to that in 1996?
Provide a succinct answer. 1. What is the ratio of the Area (% of total land area) in Uruguay in 1993 to that in 1996?
Offer a very short reply. 0.85. What is the ratio of the Area (% of total land area) of Egypt, Arab Rep. in 1993 to that in 1997?
Give a very brief answer. 0.89. What is the ratio of the Area (% of total land area) of Jordan in 1993 to that in 1997?
Offer a very short reply. 1. What is the ratio of the Area (% of total land area) of Uruguay in 1993 to that in 1997?
Make the answer very short. 0.81. What is the ratio of the Area (% of total land area) of Egypt, Arab Rep. in 1993 to that in 1998?
Your answer should be compact. 0.87. What is the ratio of the Area (% of total land area) of Uruguay in 1993 to that in 1998?
Your answer should be compact. 0.77. What is the ratio of the Area (% of total land area) in Egypt, Arab Rep. in 1994 to that in 1995?
Make the answer very short. 0.97. What is the ratio of the Area (% of total land area) of Jordan in 1994 to that in 1995?
Provide a short and direct response. 1. What is the ratio of the Area (% of total land area) in Uruguay in 1994 to that in 1995?
Offer a terse response. 0.95. What is the ratio of the Area (% of total land area) in Egypt, Arab Rep. in 1994 to that in 1996?
Provide a succinct answer. 0.94. What is the ratio of the Area (% of total land area) in Jordan in 1994 to that in 1996?
Your answer should be compact. 1. What is the ratio of the Area (% of total land area) in Uruguay in 1994 to that in 1996?
Make the answer very short. 0.9. What is the ratio of the Area (% of total land area) of Egypt, Arab Rep. in 1994 to that in 1997?
Your answer should be compact. 0.92. What is the ratio of the Area (% of total land area) of Uruguay in 1994 to that in 1997?
Your response must be concise. 0.86. What is the ratio of the Area (% of total land area) of Egypt, Arab Rep. in 1994 to that in 1998?
Ensure brevity in your answer.  0.89. What is the ratio of the Area (% of total land area) in Jordan in 1994 to that in 1998?
Your answer should be very brief. 1. What is the ratio of the Area (% of total land area) in Uruguay in 1994 to that in 1998?
Make the answer very short. 0.82. What is the ratio of the Area (% of total land area) in Egypt, Arab Rep. in 1995 to that in 1996?
Make the answer very short. 0.97. What is the ratio of the Area (% of total land area) in Jordan in 1995 to that in 1996?
Make the answer very short. 1. What is the ratio of the Area (% of total land area) in New Caledonia in 1995 to that in 1996?
Your answer should be very brief. 1. What is the ratio of the Area (% of total land area) of Uruguay in 1995 to that in 1996?
Your answer should be very brief. 0.95. What is the ratio of the Area (% of total land area) of Egypt, Arab Rep. in 1995 to that in 1997?
Give a very brief answer. 0.94. What is the ratio of the Area (% of total land area) in Jordan in 1995 to that in 1997?
Your answer should be very brief. 1. What is the ratio of the Area (% of total land area) in New Caledonia in 1995 to that in 1997?
Make the answer very short. 1. What is the ratio of the Area (% of total land area) of Uruguay in 1995 to that in 1997?
Offer a very short reply. 0.9. What is the ratio of the Area (% of total land area) in Egypt, Arab Rep. in 1995 to that in 1998?
Provide a succinct answer. 0.92. What is the ratio of the Area (% of total land area) of Jordan in 1995 to that in 1998?
Your answer should be compact. 1. What is the ratio of the Area (% of total land area) in New Caledonia in 1995 to that in 1998?
Provide a short and direct response. 1. What is the ratio of the Area (% of total land area) of Uruguay in 1995 to that in 1998?
Ensure brevity in your answer.  0.86. What is the ratio of the Area (% of total land area) in Egypt, Arab Rep. in 1996 to that in 1997?
Your response must be concise. 0.97. What is the ratio of the Area (% of total land area) in Uruguay in 1996 to that in 1997?
Offer a terse response. 0.95. What is the ratio of the Area (% of total land area) in Egypt, Arab Rep. in 1996 to that in 1998?
Offer a terse response. 0.95. What is the ratio of the Area (% of total land area) in Jordan in 1996 to that in 1998?
Offer a terse response. 1. What is the ratio of the Area (% of total land area) in Uruguay in 1996 to that in 1998?
Give a very brief answer. 0.91. What is the ratio of the Area (% of total land area) of Egypt, Arab Rep. in 1997 to that in 1998?
Your response must be concise. 0.97. What is the ratio of the Area (% of total land area) of New Caledonia in 1997 to that in 1998?
Your response must be concise. 1. What is the ratio of the Area (% of total land area) in Uruguay in 1997 to that in 1998?
Give a very brief answer. 0.95. What is the difference between the highest and the second highest Area (% of total land area) in Egypt, Arab Rep.?
Your answer should be very brief. 0. What is the difference between the highest and the second highest Area (% of total land area) in Uruguay?
Give a very brief answer. 0.33. What is the difference between the highest and the lowest Area (% of total land area) of Egypt, Arab Rep.?
Offer a very short reply. 0.01. What is the difference between the highest and the lowest Area (% of total land area) of Jordan?
Give a very brief answer. 0. What is the difference between the highest and the lowest Area (% of total land area) in Uruguay?
Provide a short and direct response. 1.96. 